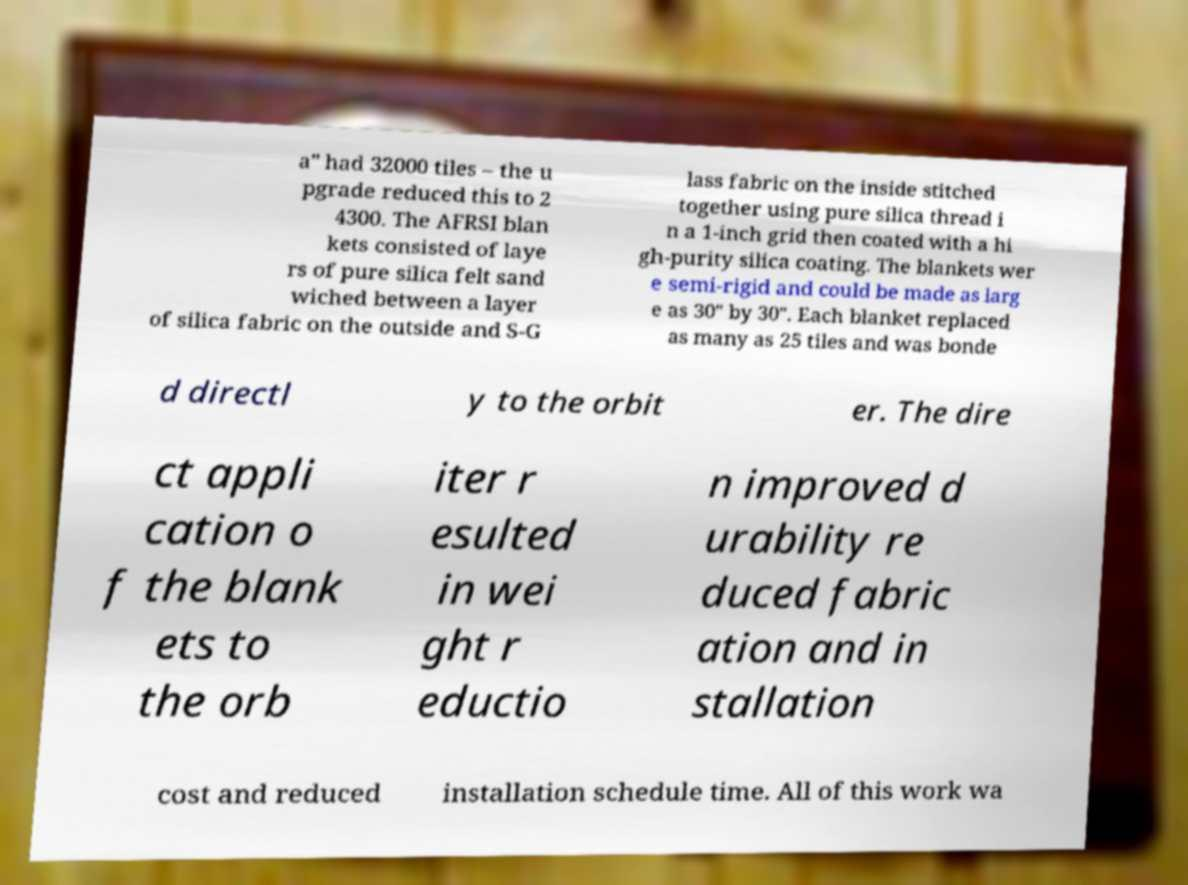Please read and relay the text visible in this image. What does it say? a" had 32000 tiles – the u pgrade reduced this to 2 4300. The AFRSI blan kets consisted of laye rs of pure silica felt sand wiched between a layer of silica fabric on the outside and S-G lass fabric on the inside stitched together using pure silica thread i n a 1-inch grid then coated with a hi gh-purity silica coating. The blankets wer e semi-rigid and could be made as larg e as 30" by 30". Each blanket replaced as many as 25 tiles and was bonde d directl y to the orbit er. The dire ct appli cation o f the blank ets to the orb iter r esulted in wei ght r eductio n improved d urability re duced fabric ation and in stallation cost and reduced installation schedule time. All of this work wa 